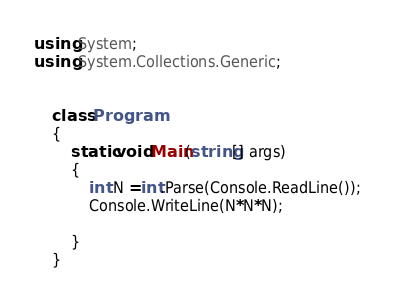Convert code to text. <code><loc_0><loc_0><loc_500><loc_500><_C#_>using System;
using System.Collections.Generic;


    class Program
    {
        static void Main(string[] args)
        {
            int N =int.Parse(Console.ReadLine());
            Console.WriteLine(N*N*N);

        }
    }</code> 